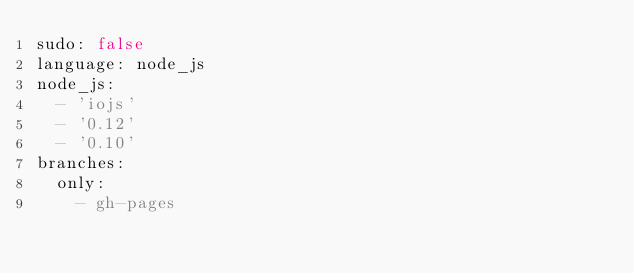Convert code to text. <code><loc_0><loc_0><loc_500><loc_500><_YAML_>sudo: false
language: node_js
node_js:
  - 'iojs'
  - '0.12'
  - '0.10'
branches:
  only:
    - gh-pages
</code> 